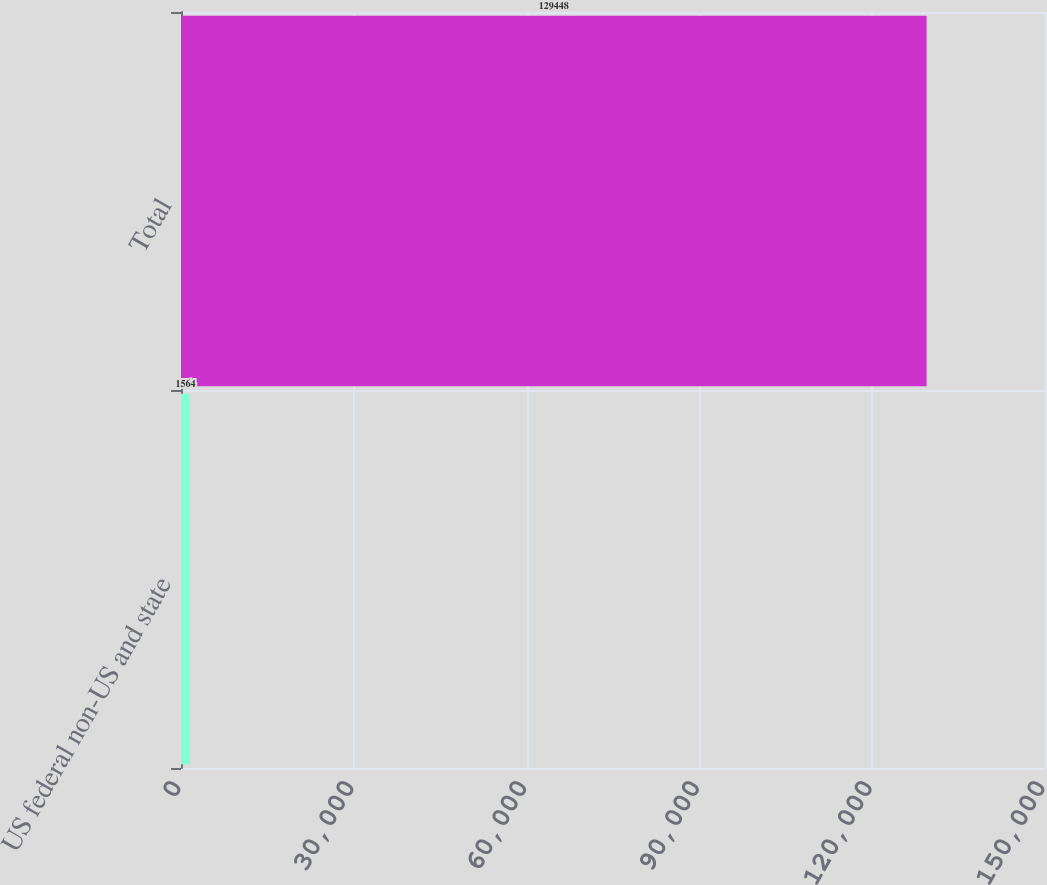Convert chart. <chart><loc_0><loc_0><loc_500><loc_500><bar_chart><fcel>US federal non-US and state<fcel>Total<nl><fcel>1564<fcel>129448<nl></chart> 